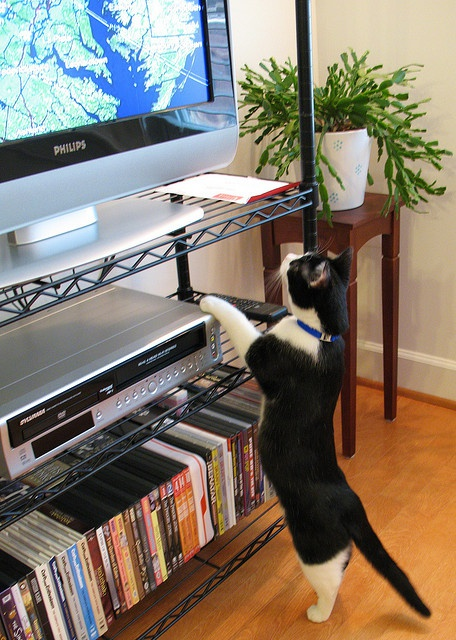Describe the objects in this image and their specific colors. I can see tv in lightblue, white, darkgray, and black tones, cat in lightblue, black, tan, and maroon tones, potted plant in lightblue, darkgreen, black, and olive tones, book in lightblue, black, maroon, olive, and brown tones, and book in lightblue, black, maroon, salmon, and brown tones in this image. 